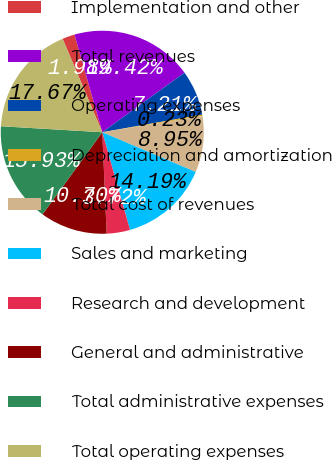Convert chart. <chart><loc_0><loc_0><loc_500><loc_500><pie_chart><fcel>Implementation and other<fcel>Total revenues<fcel>Operating expenses<fcel>Depreciation and amortization<fcel>Total cost of revenues<fcel>Sales and marketing<fcel>Research and development<fcel>General and administrative<fcel>Total administrative expenses<fcel>Total operating expenses<nl><fcel>1.98%<fcel>19.42%<fcel>7.21%<fcel>0.23%<fcel>8.95%<fcel>14.19%<fcel>3.72%<fcel>10.7%<fcel>15.93%<fcel>17.67%<nl></chart> 